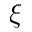Convert formula to latex. <formula><loc_0><loc_0><loc_500><loc_500>\xi</formula> 